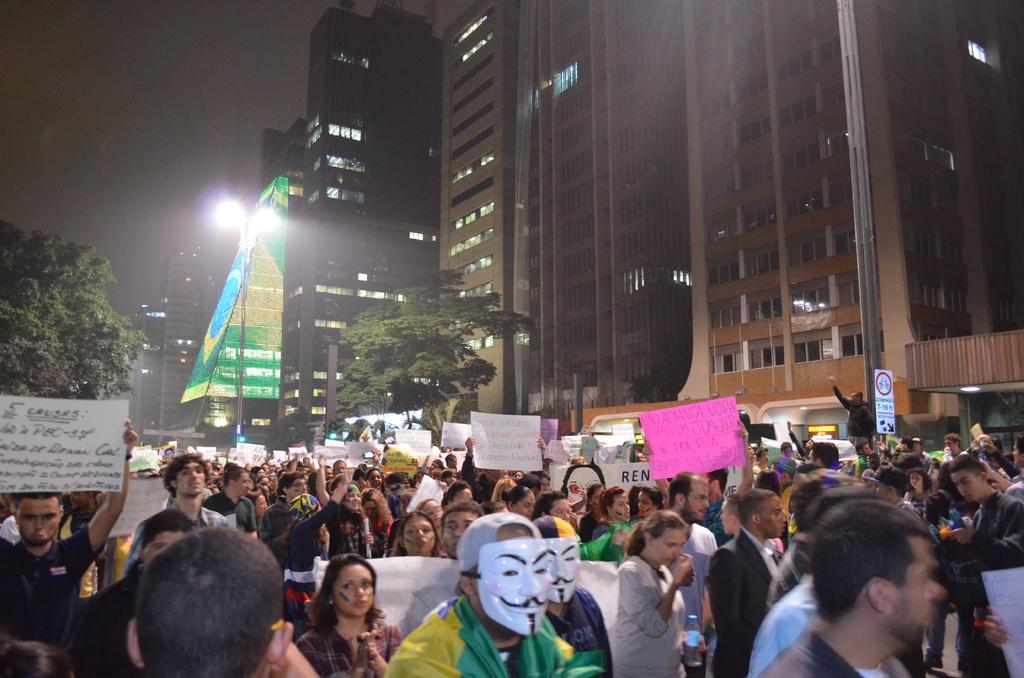Could you give a brief overview of what you see in this image? In the picture I can see a group of people are standing on the ground and holding placards in hands. In the background I can see buildings, trees, lights, the sky and some other things. 